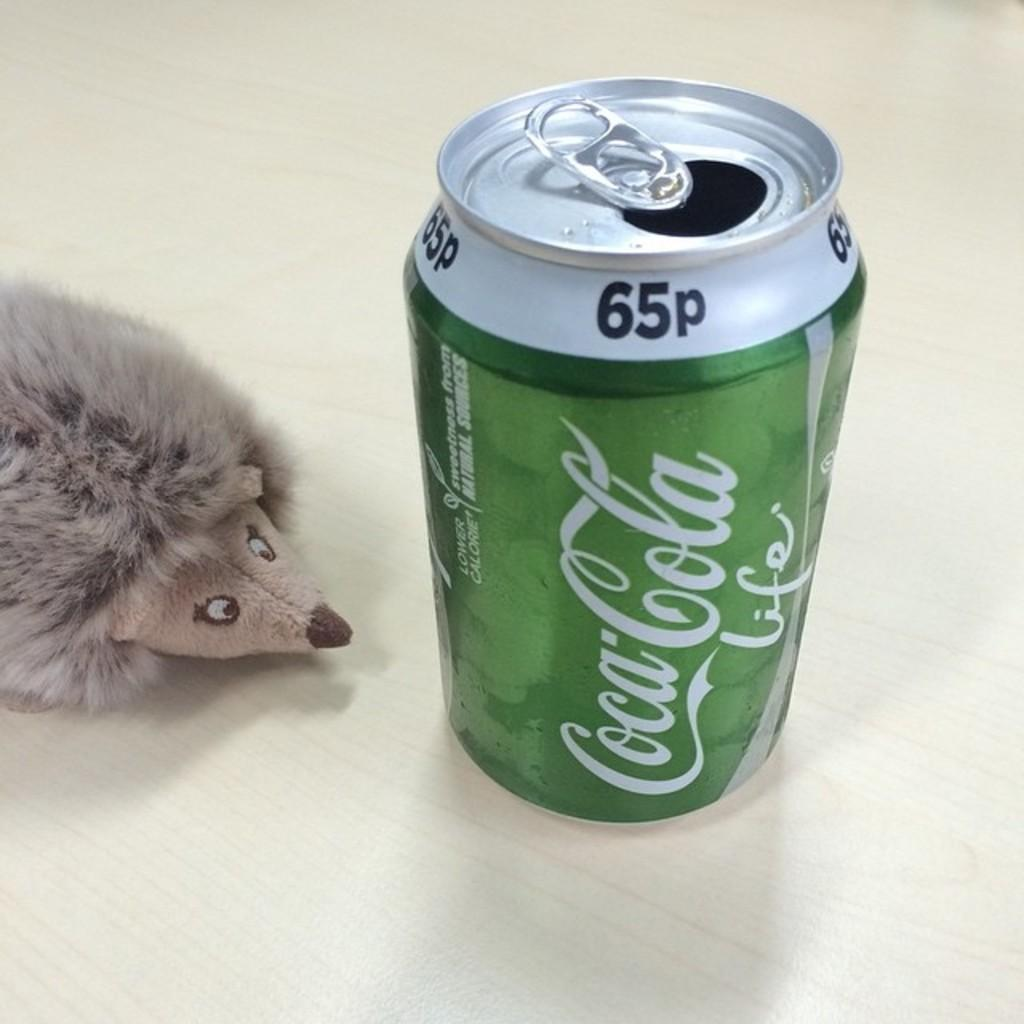What is the main object in the center of the image? There is a tin in the center of the image. What is depicted on the tin? There is a depiction of a mouse on the tin. What is the title of the book that the mouse is reading in the image? There is no book or mouse reading a book in the image; it only features a tin with a depiction of a mouse. 